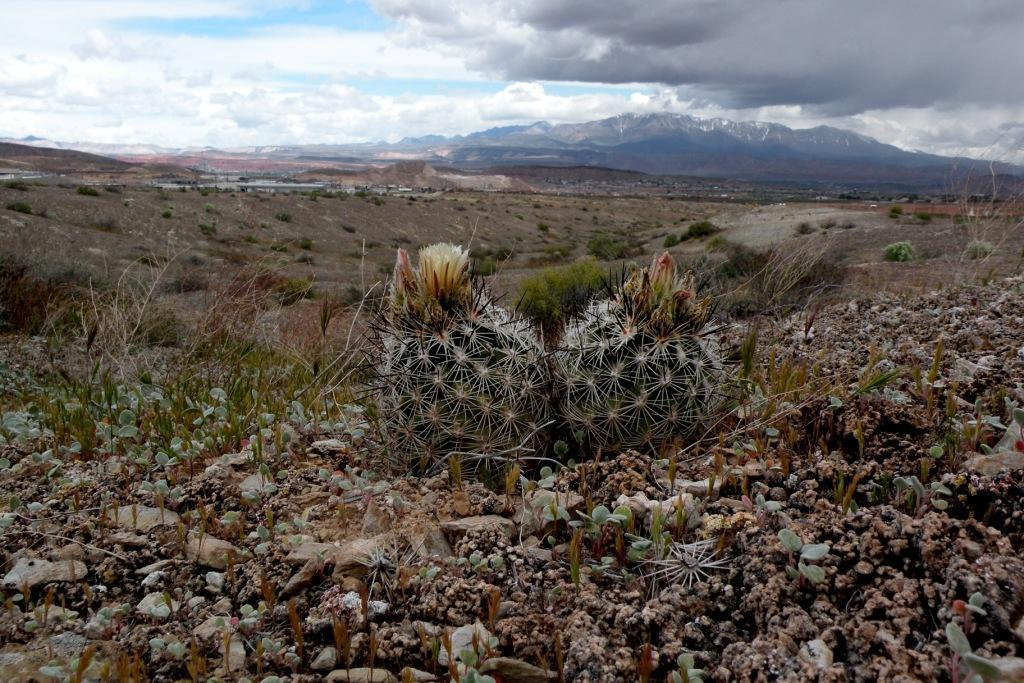What type of plants are in the foreground of the image? There are cactus and other plants in the foreground of the image. What can be seen in the background of the image? There are mountains and the sky visible in the background of the image. What type of tray is being used to hold the spark in the image? There is no tray or spark present in the image. 